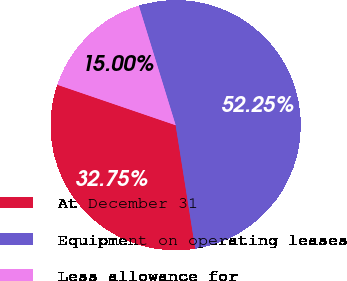<chart> <loc_0><loc_0><loc_500><loc_500><pie_chart><fcel>At December 31<fcel>Equipment on operating leases<fcel>Less allowance for<nl><fcel>32.75%<fcel>52.25%<fcel>15.0%<nl></chart> 